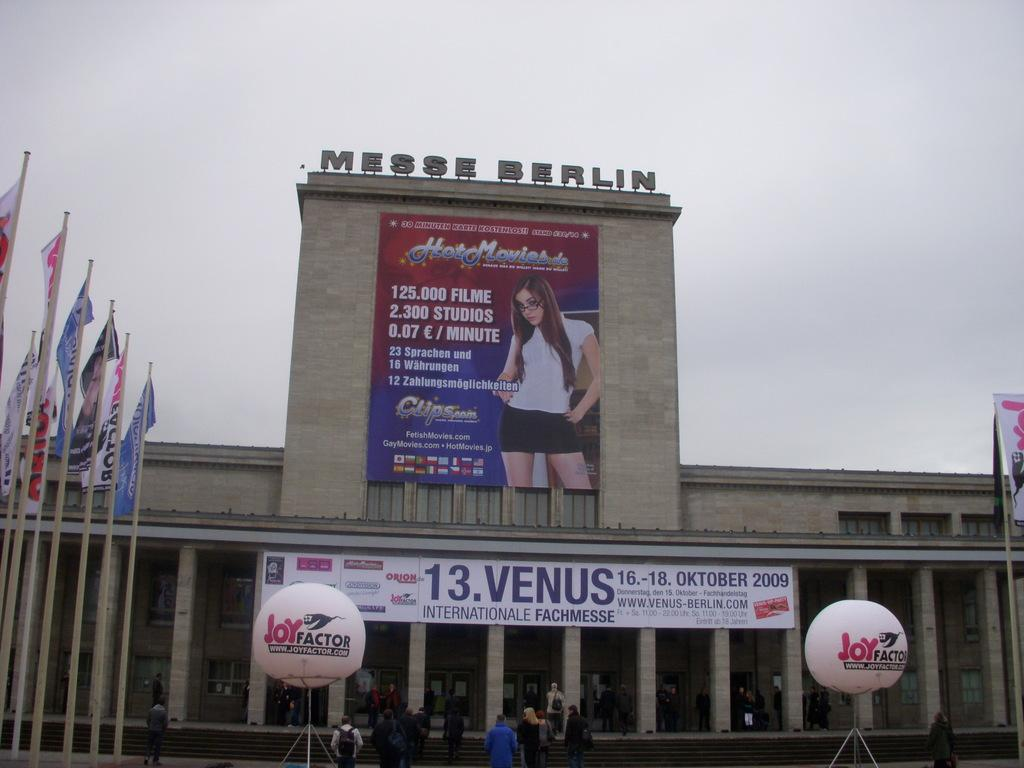<image>
Provide a brief description of the given image. The Messe Berlin Venue with a post title Hot Movies with and image of a woman on it. 